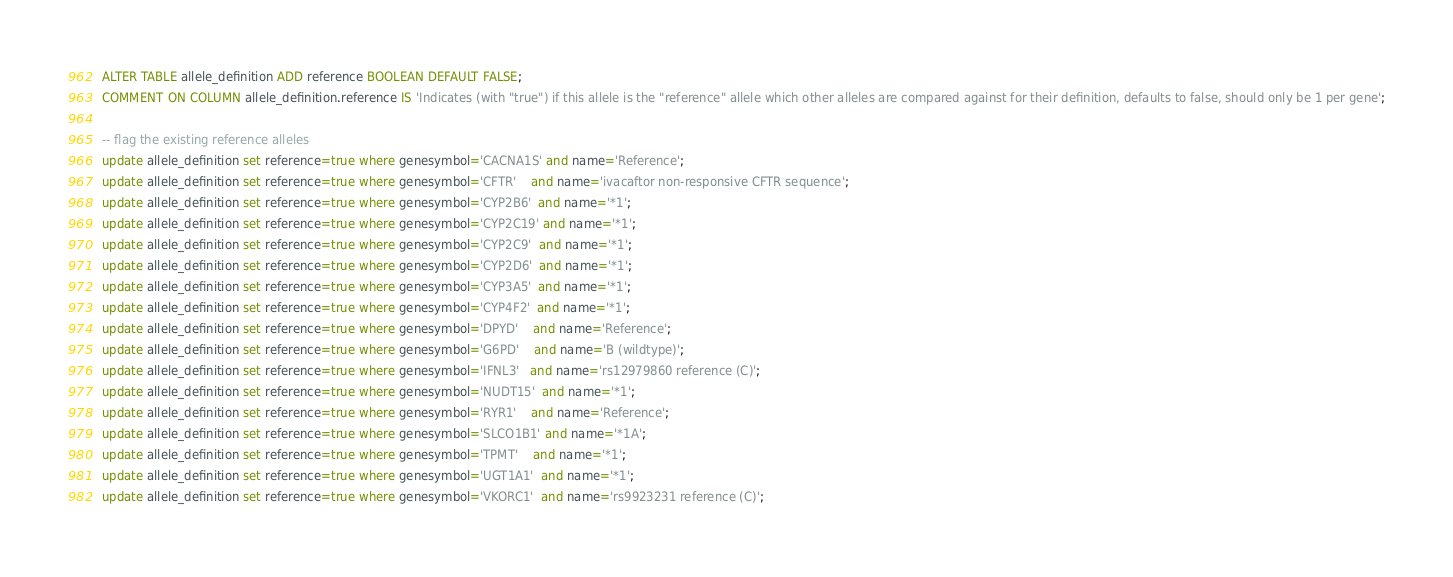<code> <loc_0><loc_0><loc_500><loc_500><_SQL_>ALTER TABLE allele_definition ADD reference BOOLEAN DEFAULT FALSE;
COMMENT ON COLUMN allele_definition.reference IS 'Indicates (with "true") if this allele is the "reference" allele which other alleles are compared against for their definition, defaults to false, should only be 1 per gene';

-- flag the existing reference alleles
update allele_definition set reference=true where genesymbol='CACNA1S' and name='Reference';
update allele_definition set reference=true where genesymbol='CFTR'    and name='ivacaftor non-responsive CFTR sequence';
update allele_definition set reference=true where genesymbol='CYP2B6'  and name='*1';
update allele_definition set reference=true where genesymbol='CYP2C19' and name='*1';
update allele_definition set reference=true where genesymbol='CYP2C9'  and name='*1';
update allele_definition set reference=true where genesymbol='CYP2D6'  and name='*1';
update allele_definition set reference=true where genesymbol='CYP3A5'  and name='*1';
update allele_definition set reference=true where genesymbol='CYP4F2'  and name='*1';
update allele_definition set reference=true where genesymbol='DPYD'    and name='Reference';
update allele_definition set reference=true where genesymbol='G6PD'    and name='B (wildtype)';
update allele_definition set reference=true where genesymbol='IFNL3'   and name='rs12979860 reference (C)';
update allele_definition set reference=true where genesymbol='NUDT15'  and name='*1';
update allele_definition set reference=true where genesymbol='RYR1'    and name='Reference';
update allele_definition set reference=true where genesymbol='SLCO1B1' and name='*1A';
update allele_definition set reference=true where genesymbol='TPMT'    and name='*1';
update allele_definition set reference=true where genesymbol='UGT1A1'  and name='*1';
update allele_definition set reference=true where genesymbol='VKORC1'  and name='rs9923231 reference (C)';
</code> 